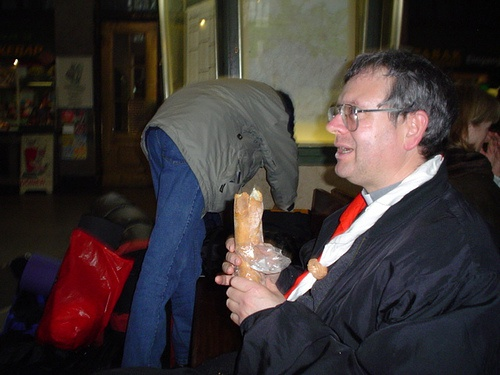Describe the objects in this image and their specific colors. I can see people in black, lightpink, and gray tones, people in black, gray, navy, and darkblue tones, sandwich in black and tan tones, and people in black, maroon, and brown tones in this image. 